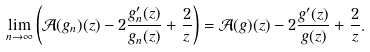<formula> <loc_0><loc_0><loc_500><loc_500>\lim _ { n \rightarrow \infty } \left ( \mathcal { A } ( g _ { n } ) ( z ) - 2 \frac { g _ { n } ^ { \prime } ( z ) } { g _ { n } ( z ) } + \frac { 2 } { z } \right ) = \mathcal { A } ( g ) ( z ) - 2 \frac { g ^ { \prime } ( z ) } { g ( z ) } + \frac { 2 } { z } .</formula> 